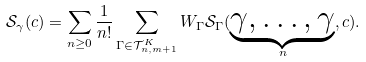Convert formula to latex. <formula><loc_0><loc_0><loc_500><loc_500>\mathcal { S } _ { \gamma } ( c ) = \sum _ { n \geq 0 } \frac { 1 } { n ! } \sum _ { \Gamma \in \mathcal { T } _ { n , m + 1 } ^ { K } } W _ { \Gamma } \mathcal { S } _ { \Gamma } ( \underset { n } { \underbrace { \gamma , \dots , \gamma } } , c ) .</formula> 